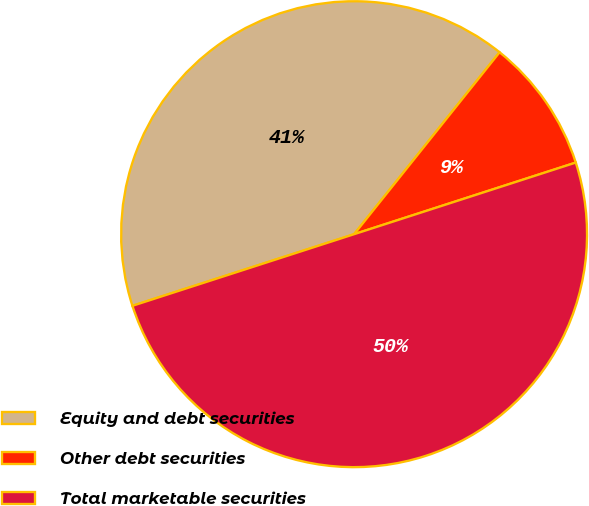<chart> <loc_0><loc_0><loc_500><loc_500><pie_chart><fcel>Equity and debt securities<fcel>Other debt securities<fcel>Total marketable securities<nl><fcel>40.71%<fcel>9.29%<fcel>50.0%<nl></chart> 